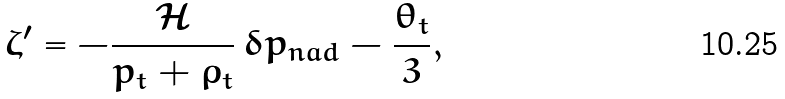<formula> <loc_0><loc_0><loc_500><loc_500>\zeta ^ { \prime } = - \frac { \mathcal { H } } { p _ { t } + \rho _ { t } } \, \delta p _ { n a d } - \frac { \theta _ { t } } { 3 } ,</formula> 